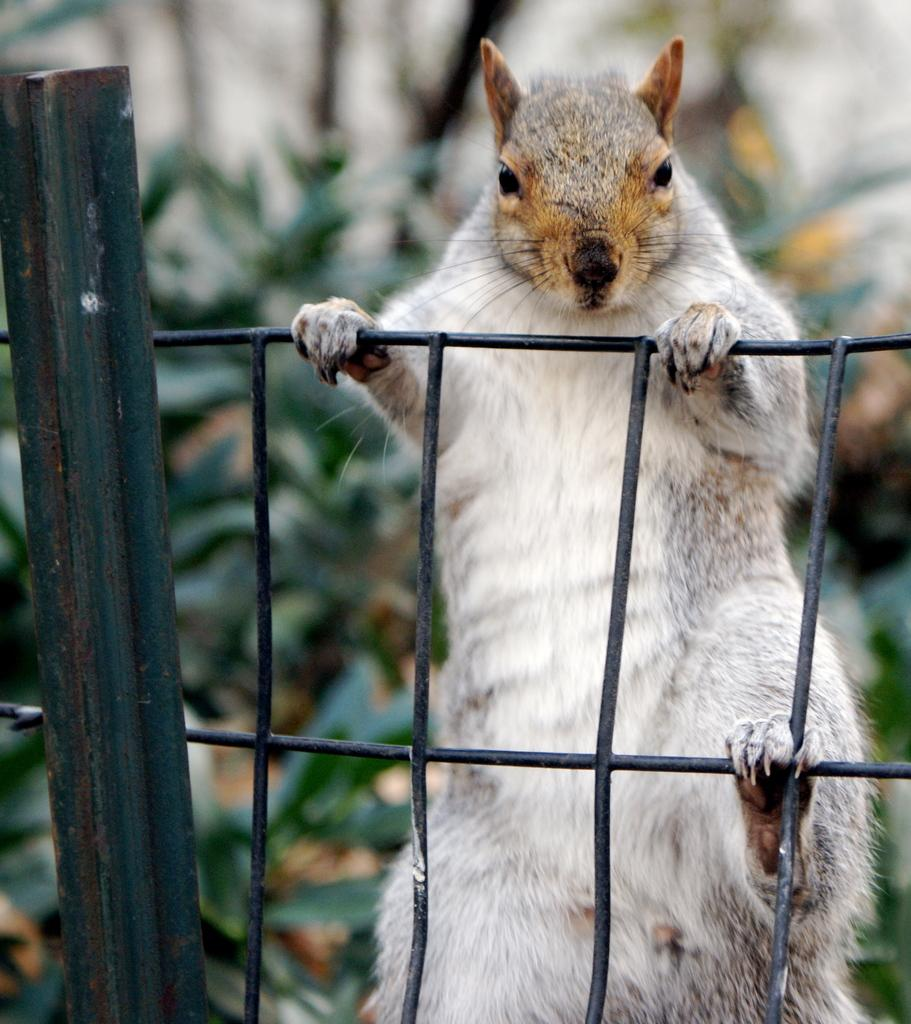What animal can be seen on the fence in the image? There is a squirrel on the fence in the image. What type of vegetation is present in the image? There are plants in the image. What other object can be seen in the image besides the squirrel and plants? There is a pole in the image. What type of ocean current can be seen in the image? There is no ocean or current present in the image; it features a squirrel on a fence, plants, and a pole. How many buckets are visible in the image? There are no buckets present in the image. 